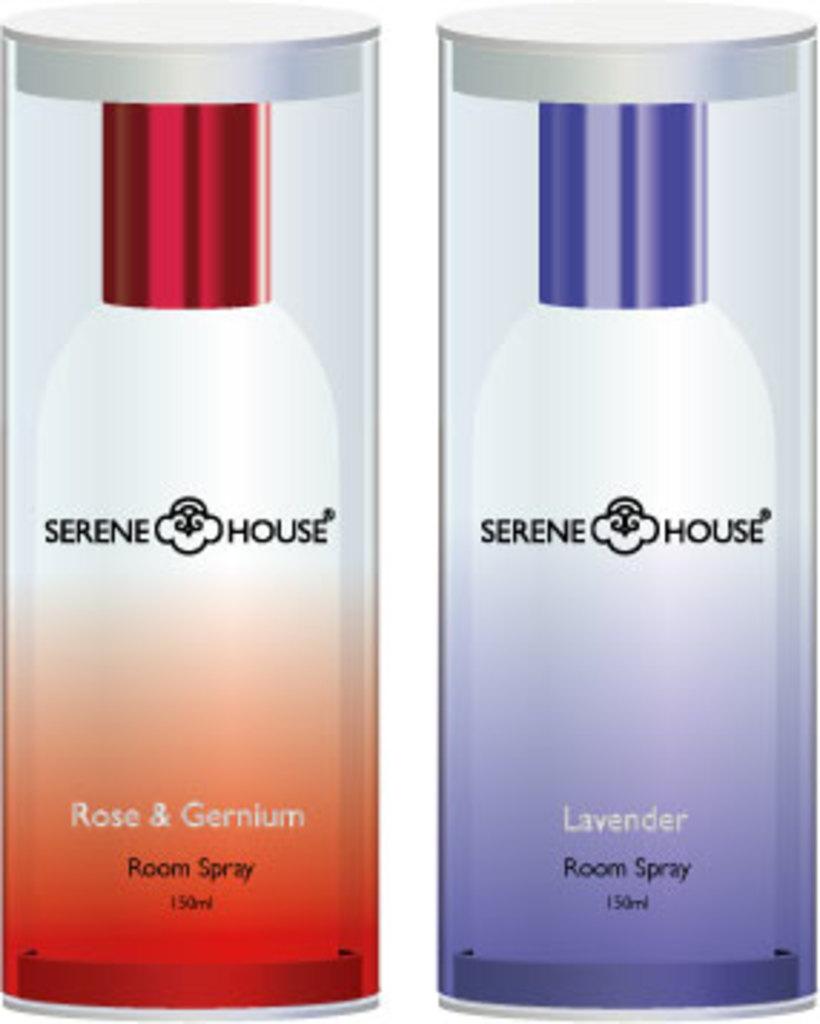What is the scent for the blue container?
Provide a short and direct response. Lavender. This are parfum for man and woman?
Ensure brevity in your answer.  No. 